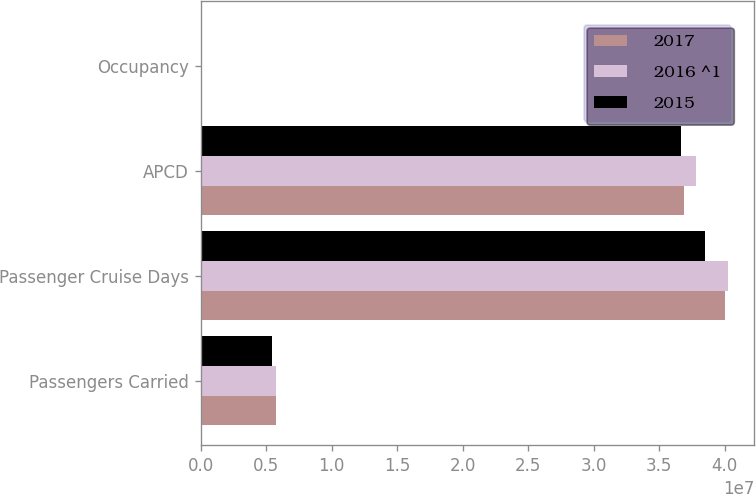Convert chart to OTSL. <chart><loc_0><loc_0><loc_500><loc_500><stacked_bar_chart><ecel><fcel>Passengers Carried<fcel>Passenger Cruise Days<fcel>APCD<fcel>Occupancy<nl><fcel>2017<fcel>5.7685e+06<fcel>4.00335e+07<fcel>3.69309e+07<fcel>108.4<nl><fcel>2016 ^1<fcel>5.75475e+06<fcel>4.02506e+07<fcel>3.78446e+07<fcel>106.4<nl><fcel>2015<fcel>5.4019e+06<fcel>3.85231e+07<fcel>3.66466e+07<fcel>105.1<nl></chart> 